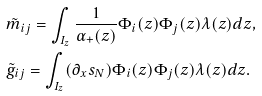Convert formula to latex. <formula><loc_0><loc_0><loc_500><loc_500>& \tilde { m } _ { i j } = \int _ { I _ { z } } \frac { 1 } { \alpha _ { + } ( z ) } \Phi _ { i } ( z ) \Phi _ { j } ( z ) \lambda ( z ) d z , \\ & \tilde { g } _ { i j } = \int _ { I _ { z } } ( \partial _ { x } s _ { N } ) \Phi _ { i } ( z ) \Phi _ { j } ( z ) \lambda ( z ) d z .</formula> 